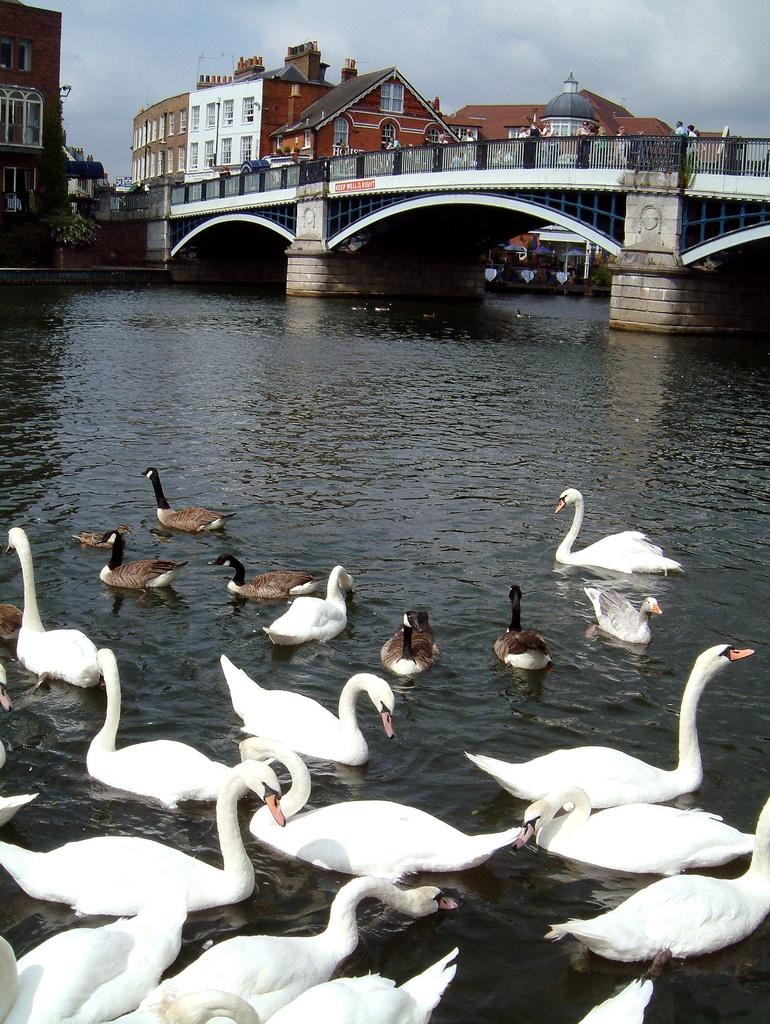What type of animals can be seen in the water in the image? There are swans and ducks in the water in the image. What is visible in the image besides the animals? There is water, buildings, a bridge, and people visible in the image. Where is the bridge located in the image? The bridge is in the background of the image, over the water. What are the people on the bridge doing? The people on the bridge are not specified, but they might be walking, standing, or observing the water. What letters are being delivered by the passenger on the toy boat in the image? There is no toy boat or passenger delivering letters in the image; it only features swans, ducks, water, buildings, a bridge, and people. 